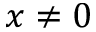<formula> <loc_0><loc_0><loc_500><loc_500>x \neq 0</formula> 